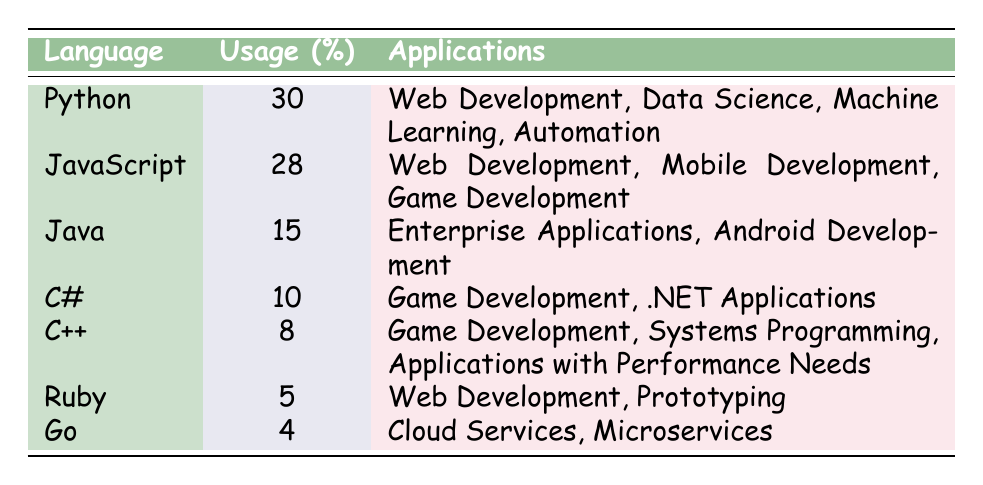What programming language has the highest usage percentage in 2023? From the table, Python has the highest usage percentage listed at 30%.
Answer: Python How many programming languages have a usage percentage of 10% or higher? The languages with usage percentages of 10% or higher are Python (30%), JavaScript (28%), Java (15%), and C# (10%), totaling four languages.
Answer: 4 Is Go used more than Ruby in 2023? Go’s usage percentage is 4%, whereas Ruby’s usage percentage is 5%. Therefore, Ruby is used more than Go.
Answer: No What are the applications of JavaScript? JavaScript's applications listed in the table include Web Development, Mobile Development, and Game Development.
Answer: Web Development, Mobile Development, Game Development What is the total percentage usage of the top three programming languages? The top three programming languages by usage are Python (30%), JavaScript (28%), and Java (15%). Adding these gives 30 + 28 + 15 = 73%.
Answer: 73% Does C++ and C# have the same application in game development? C++ and C# both mention Game Development as an application, indicating they share this specific application area.
Answer: Yes What is the average usage percentage of the programming languages listed? To find the average, we sum the usage percentages of all languages: 30 + 28 + 15 + 10 + 8 + 5 + 4 = 100. There are 7 languages, so the average is 100/7 ≈ 14.29%.
Answer: 14.29% Which programming language has the least usage, and what are its applications? Go has the least usage percentage at 4%, with its applications being Cloud Services and Microservices.
Answer: Go; Cloud Services, Microservices How does the usage percentage of Java compare to that of Python? Java's usage percentage is 15%, while Python's usage percentage is 30%. Therefore, Python's usage is higher than Java's.
Answer: Python is higher 